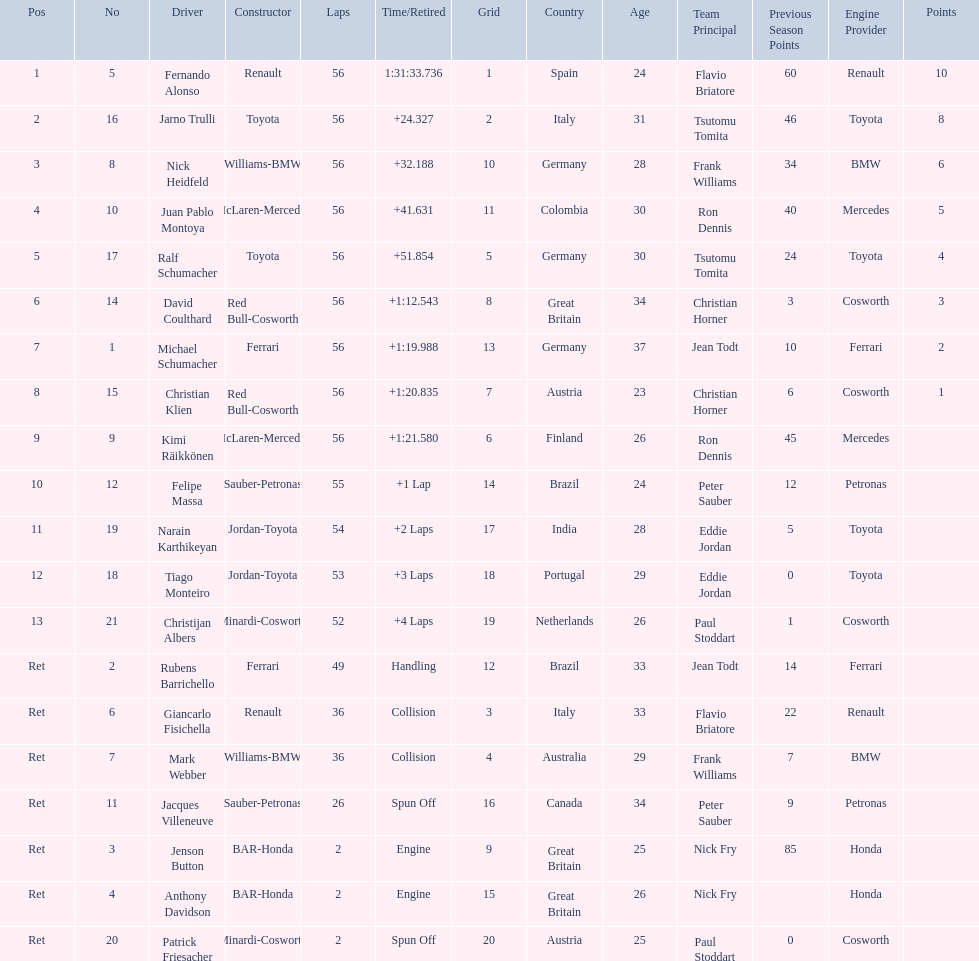How many germans finished in the top five? 2. 